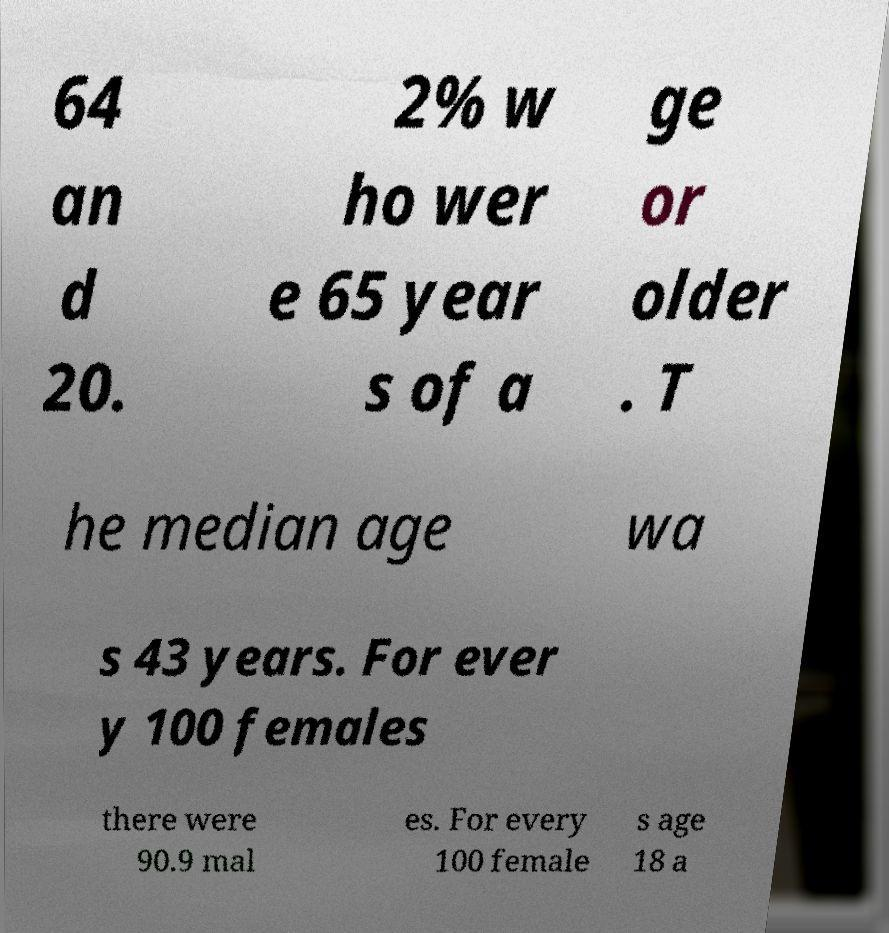There's text embedded in this image that I need extracted. Can you transcribe it verbatim? 64 an d 20. 2% w ho wer e 65 year s of a ge or older . T he median age wa s 43 years. For ever y 100 females there were 90.9 mal es. For every 100 female s age 18 a 